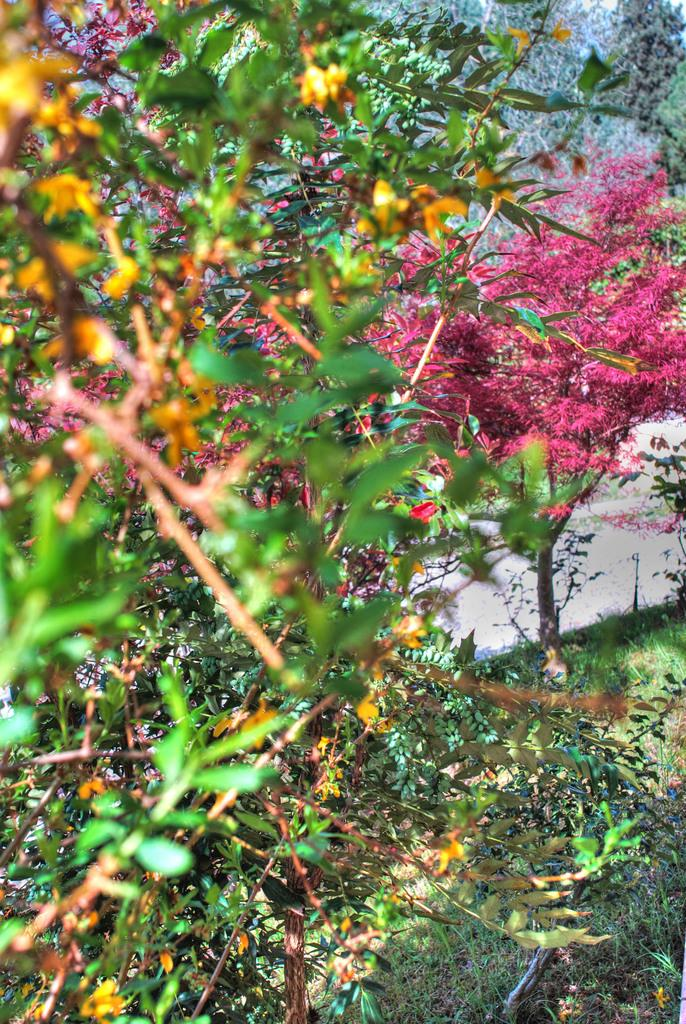What type of vegetation can be seen in the image? There is grass and trees in the image. Can you describe the natural environment depicted in the image? The image features grass and trees, which suggests a natural setting. What scientific discovery is being made in the image? There is no scientific discovery or activity depicted in the image; it features grass and trees. What type of urban environment is shown in the image? The image does not depict an urban environment; it features grass and trees in a natural setting. 